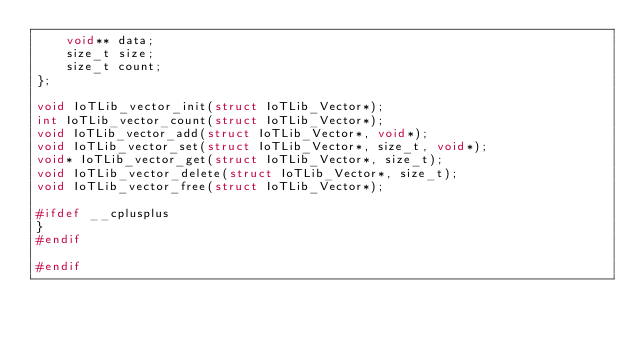<code> <loc_0><loc_0><loc_500><loc_500><_C_>    void** data;
    size_t size;
    size_t count;
};

void IoTLib_vector_init(struct IoTLib_Vector*);
int IoTLib_vector_count(struct IoTLib_Vector*);
void IoTLib_vector_add(struct IoTLib_Vector*, void*);
void IoTLib_vector_set(struct IoTLib_Vector*, size_t, void*);
void* IoTLib_vector_get(struct IoTLib_Vector*, size_t);
void IoTLib_vector_delete(struct IoTLib_Vector*, size_t);
void IoTLib_vector_free(struct IoTLib_Vector*);

#ifdef __cplusplus
}
#endif

#endif
</code> 